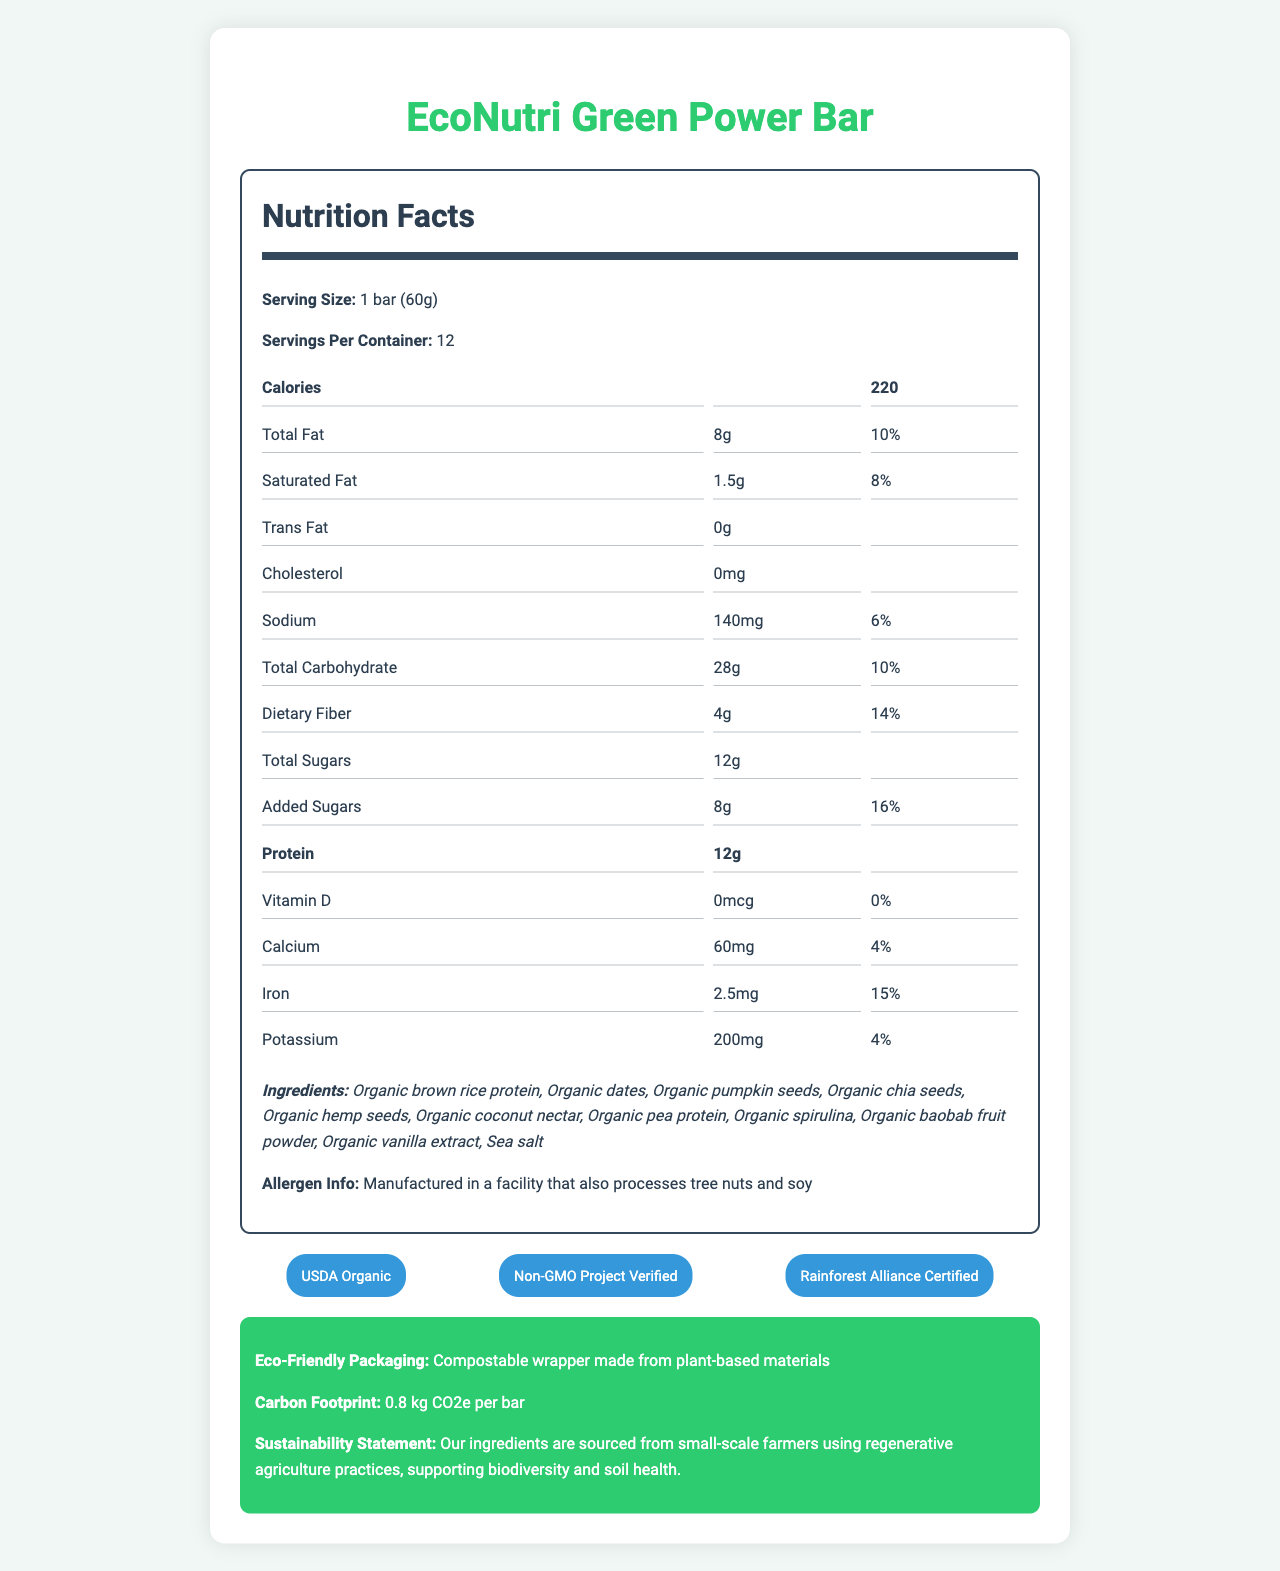What is the serving size for the EcoNutri Green Power Bar? The serving size is clearly stated in the "Serving Size" section of the document.
Answer: 1 bar (60g) How many servings are there per container? The servings per container are listed as 12 in the "Servings Per Container" section.
Answer: 12 What is the amount of protein per serving? The protein content per serving is listed as 12g in the Nutrition Facts section.
Answer: 12g How much iron is in a serving, and what percentage of the daily value does it represent? The iron content per serving is 2.5mg, which is 15% of the daily value, as stated in the Nutrition Facts.
Answer: 2.5mg, 15% Which ingredient is listed first in the ingredients list? The first ingredient listed in the Ingredients section is Organic brown rice protein.
Answer: Organic brown rice protein What certification ensures that the ingredients are organic? A. USDA Organic B. Non-GMO Project Verified C. Rainforest Alliance Certified The USDA Organic certification ensures that the ingredients are organic.
Answer: A. USDA Organic Which of these certifications does the EcoNutri Green Power Bar NOT have? A. Fair Trade Certified B. USDA Organic C. Non-GMO Project Verified The certifications listed are USDA Organic, Non-GMO Project Verified, and Rainforest Alliance Certified. Fair Trade Certified is not listed.
Answer: A. Fair Trade Certified Does the EcoNutri Green Power Bar use eco-friendly packaging? The document states that the bar uses a compostable wrapper made from plant-based materials under the Eco-Friendly Packaging section.
Answer: Yes Describe the main idea of the document. The document includes a comprehensive look at the bar's nutrition facts, highlights its sustainable ingredients and eco-friendly packaging, and lists various certifications to assure quality and sustainability.
Answer: The document provides detailed information about the EcoNutri Green Power Bar's nutritional content, ingredients, allergen info, certifications, and sustainability practices. What is the main source of protein in the EcoNutri Green Power Bar? The specific main source of protein is not provided. Multiple ingredients could be contributing to the protein content, including organic brown rice protein and organic pea protein.
Answer: Not enough information What is the total amount of sugars per serving, including added sugars? The total amount of sugars per serving is 12g, which includes 8g of added sugars. This is detailed in the Total Sugars and Added Sugars sections.
Answer: 12g total sugars, 8g added sugars 